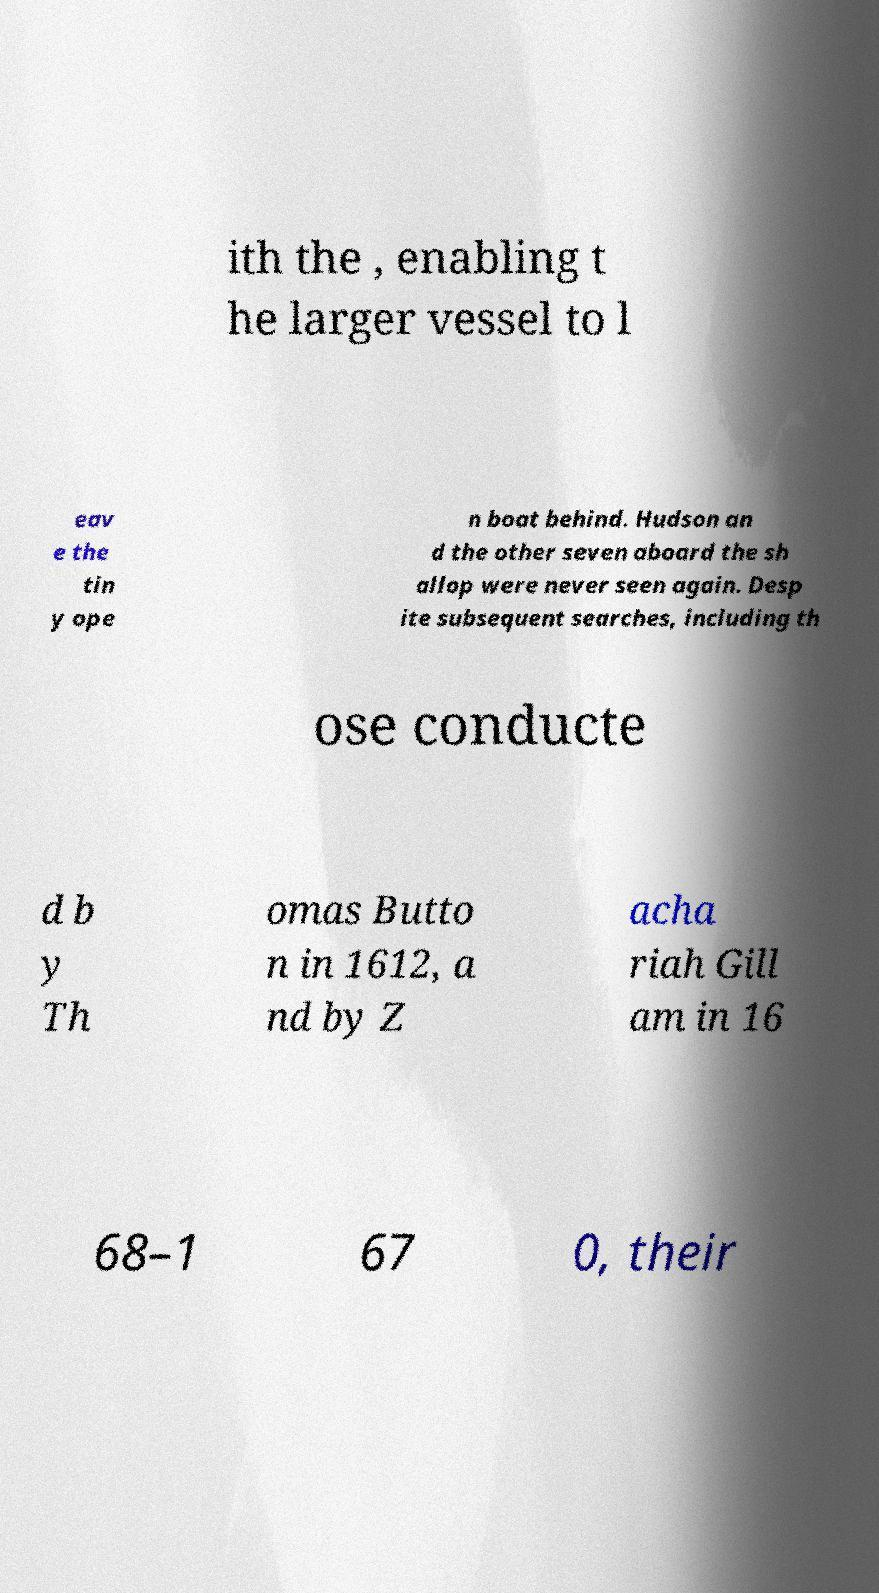Can you accurately transcribe the text from the provided image for me? ith the , enabling t he larger vessel to l eav e the tin y ope n boat behind. Hudson an d the other seven aboard the sh allop were never seen again. Desp ite subsequent searches, including th ose conducte d b y Th omas Butto n in 1612, a nd by Z acha riah Gill am in 16 68–1 67 0, their 